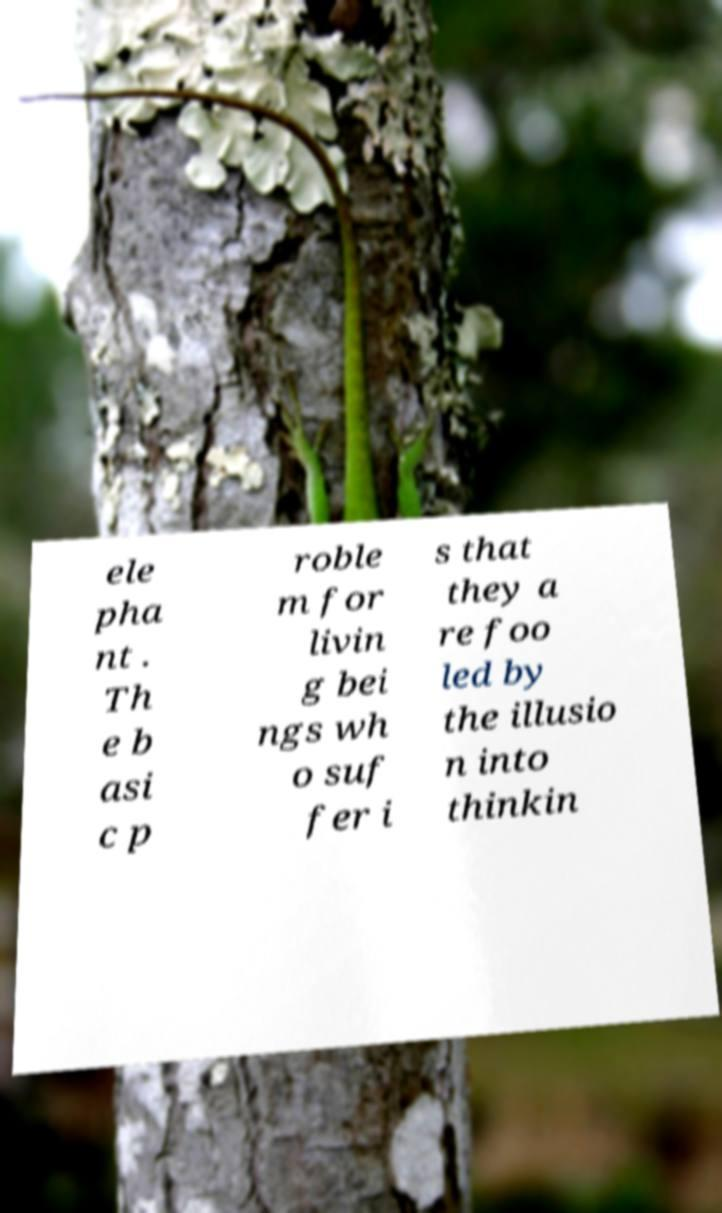Could you assist in decoding the text presented in this image and type it out clearly? ele pha nt . Th e b asi c p roble m for livin g bei ngs wh o suf fer i s that they a re foo led by the illusio n into thinkin 